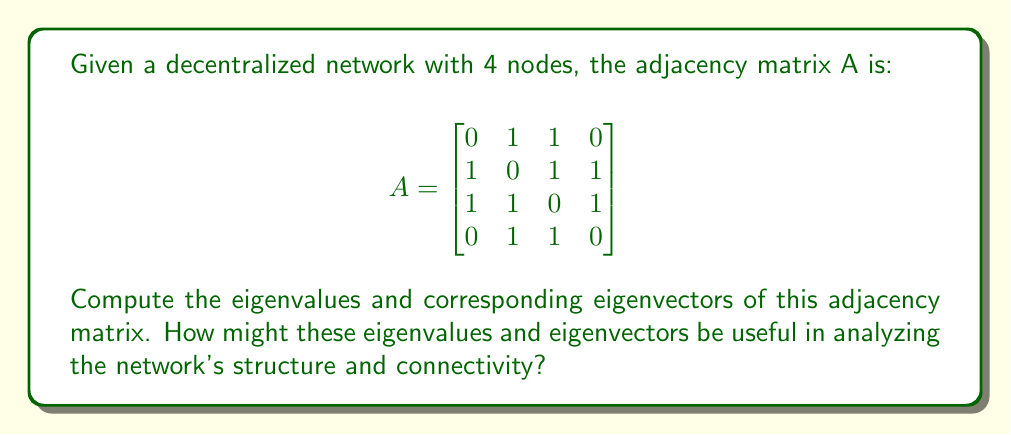Help me with this question. To find the eigenvalues and eigenvectors of the adjacency matrix A, we follow these steps:

1. Find the characteristic polynomial:
   $det(A - \lambda I) = 0$

   $$ \begin{vmatrix}
   -\lambda & 1 & 1 & 0 \\
   1 & -\lambda & 1 & 1 \\
   1 & 1 & -\lambda & 1 \\
   0 & 1 & 1 & -\lambda
   \end{vmatrix} = 0 $$

2. Expand the determinant:
   $\lambda^4 - 3\lambda^2 - 2\lambda - 1 = 0$

3. Solve the characteristic equation:
   The roots of this equation are the eigenvalues. They are:
   $\lambda_1 = 2.17228$
   $\lambda_2 = -1.61803$
   $\lambda_3 = 0.61803$
   $\lambda_4 = -1.17228$

4. For each eigenvalue $\lambda_i$, solve $(A - \lambda_i I)v = 0$ to find the corresponding eigenvector $v_i$:

   For $\lambda_1 = 2.17228$:
   $v_1 \approx (0.5, 0.7071, 0.7071, 0.5)^T$

   For $\lambda_2 = -1.61803$:
   $v_2 \approx (-0.7071, 0.5, -0.5, 0.7071)^T$

   For $\lambda_3 = 0.61803$:
   $v_3 \approx (0.7071, -0.5, 0.5, -0.7071)^T$

   For $\lambda_4 = -1.17228$:
   $v_4 \approx (-0.5, 0.7071, -0.7071, 0.5)^T$

These eigenvalues and eigenvectors provide important information about the network:

1. The largest eigenvalue ($\lambda_1$) is related to the network's overall connectivity. A larger value indicates a more connected network.

2. The eigenvector corresponding to the largest eigenvalue ($v_1$) gives a measure of each node's centrality in the network. Nodes with larger components in this eigenvector are more central to the network's structure.

3. The number of positive eigenvalues is related to the network's bipartiteness. This network has two positive eigenvalues, indicating it is not bipartite.

4. The eigenvalue spectrum (distribution of eigenvalues) can be used to detect symmetries and regularities in the network structure.

5. In secure, decentralized networking systems, these properties can be used to analyze the robustness of the network, identify potential bottlenecks or vulnerabilities, and optimize data flow and security protocols.
Answer: Eigenvalues: $\lambda_1 \approx 2.17228$, $\lambda_2 \approx -1.61803$, $\lambda_3 \approx 0.61803$, $\lambda_4 \approx -1.17228$

Eigenvectors:
$v_1 \approx (0.5, 0.7071, 0.7071, 0.5)^T$
$v_2 \approx (-0.7071, 0.5, -0.5, 0.7071)^T$
$v_3 \approx (0.7071, -0.5, 0.5, -0.7071)^T$
$v_4 \approx (-0.5, 0.7071, -0.7071, 0.5)^T$

These eigenvalues and eigenvectors provide insights into network connectivity, node centrality, bipartiteness, and overall structure, which are crucial for analyzing and optimizing secure, decentralized networking systems. 